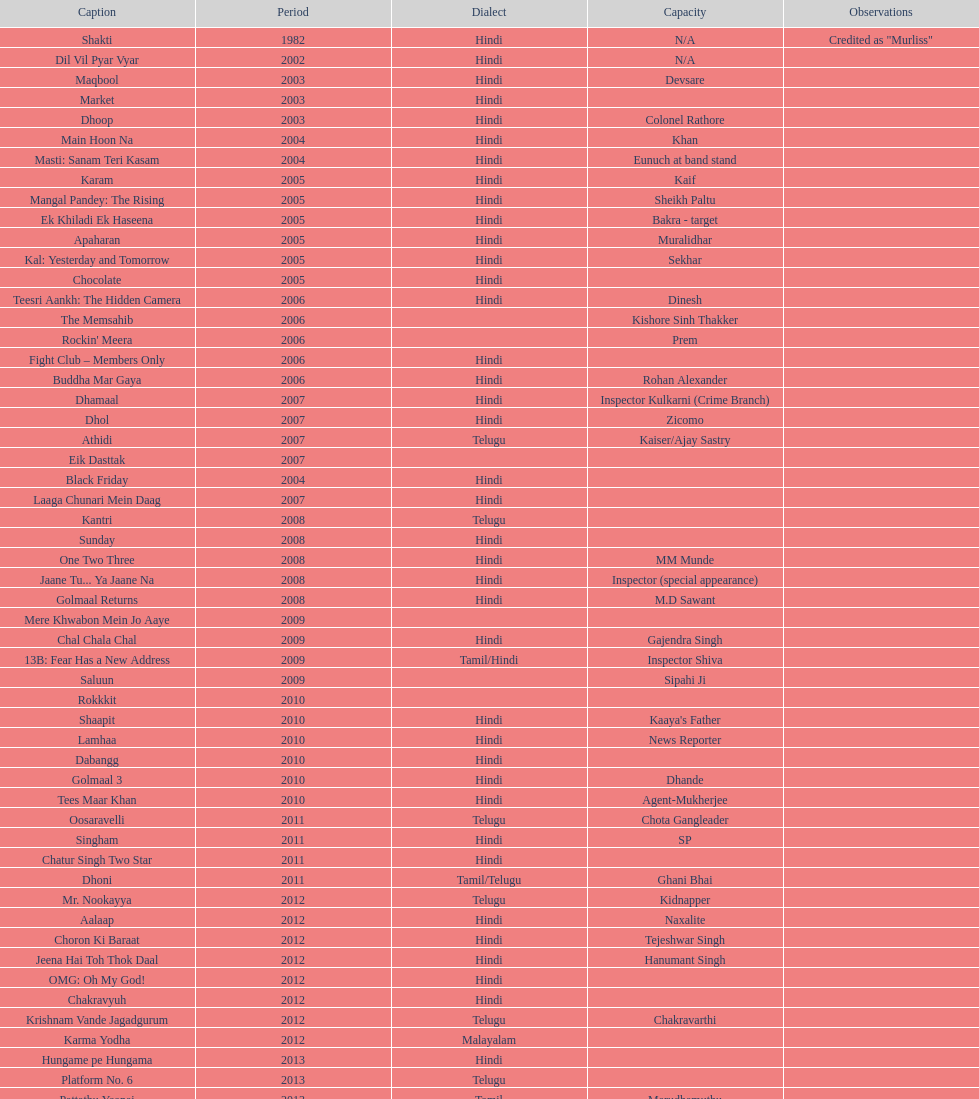What movie did this actor star in after they starred in dil vil pyar vyar in 2002? Maqbool. 